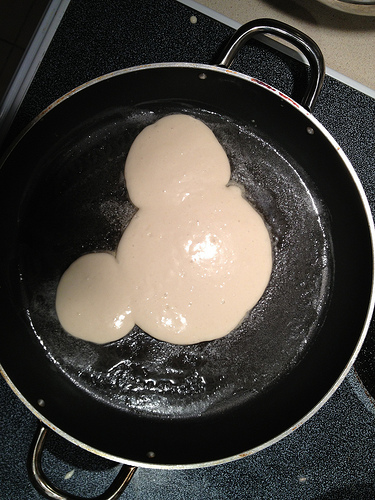<image>
Can you confirm if the pancakes is next to the frying pan? No. The pancakes is not positioned next to the frying pan. They are located in different areas of the scene. Is the batter above the pan? No. The batter is not positioned above the pan. The vertical arrangement shows a different relationship. 